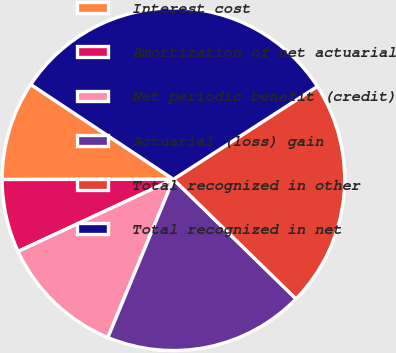<chart> <loc_0><loc_0><loc_500><loc_500><pie_chart><fcel>Interest cost<fcel>Amortization of net actuarial<fcel>Net periodic benefit (credit)<fcel>Actuarial (loss) gain<fcel>Total recognized in other<fcel>Total recognized in net<nl><fcel>9.36%<fcel>6.9%<fcel>11.83%<fcel>18.95%<fcel>21.42%<fcel>31.55%<nl></chart> 